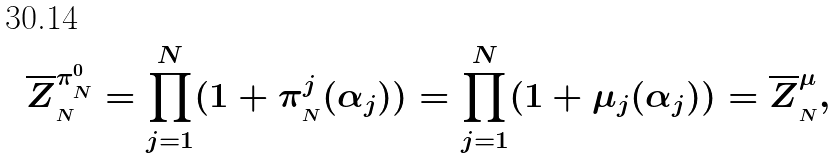Convert formula to latex. <formula><loc_0><loc_0><loc_500><loc_500>\overline { Z } _ { _ { N } } ^ { \pi ^ { 0 } _ { _ { N } } } = \prod _ { j = 1 } ^ { N } ( 1 + \pi _ { _ { N } } ^ { j } ( \alpha _ { j } ) ) = \prod _ { j = 1 } ^ { N } ( 1 + \mu _ { j } ( \alpha _ { j } ) ) = \overline { Z } _ { _ { N } } ^ { \mu } ,</formula> 